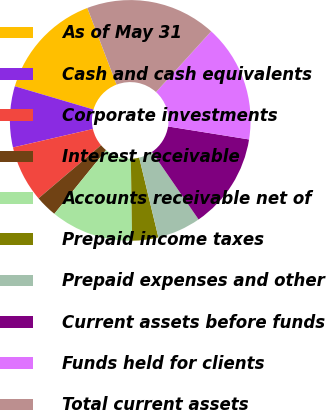<chart> <loc_0><loc_0><loc_500><loc_500><pie_chart><fcel>As of May 31<fcel>Cash and cash equivalents<fcel>Corporate investments<fcel>Interest receivable<fcel>Accounts receivable net of<fcel>Prepaid income taxes<fcel>Prepaid expenses and other<fcel>Current assets before funds<fcel>Funds held for clients<fcel>Total current assets<nl><fcel>14.62%<fcel>8.19%<fcel>7.6%<fcel>2.93%<fcel>11.11%<fcel>3.51%<fcel>5.85%<fcel>12.86%<fcel>15.79%<fcel>17.54%<nl></chart> 